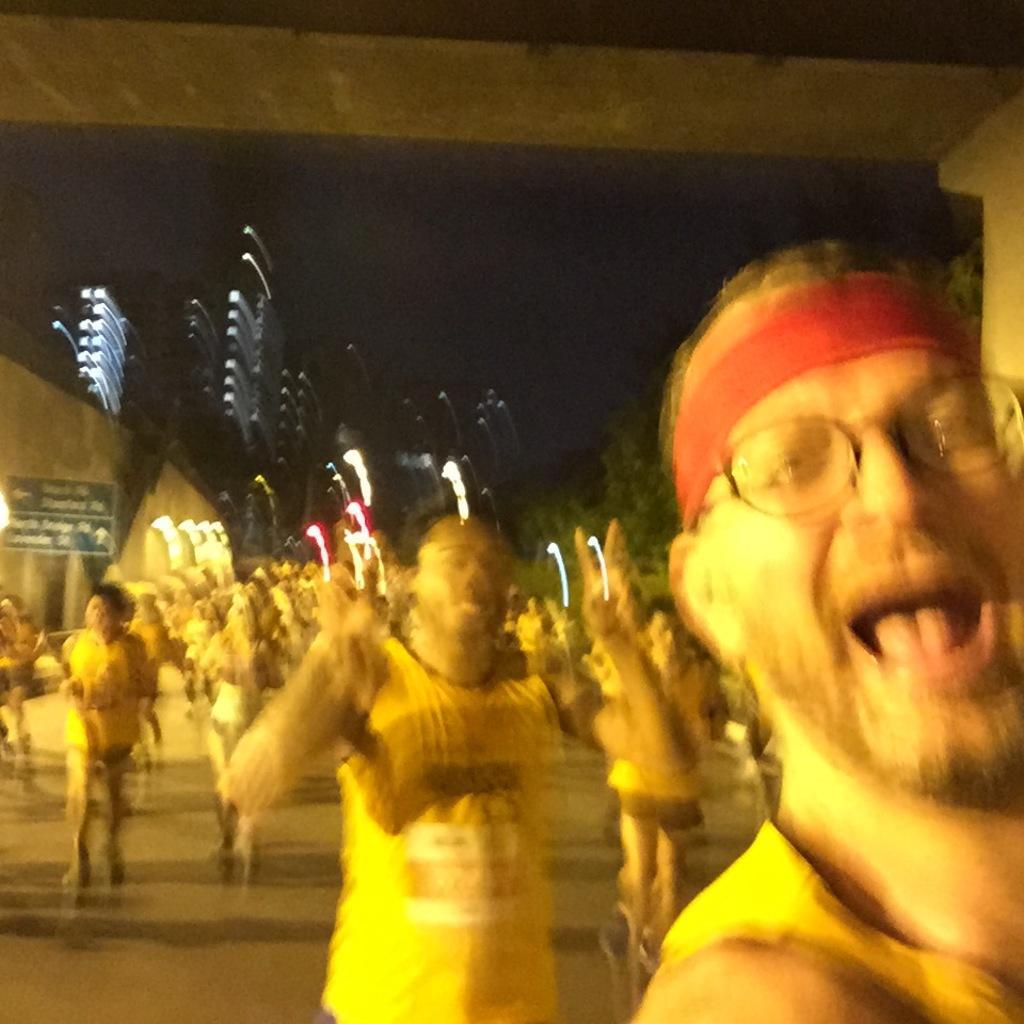In one or two sentences, can you explain what this image depicts? In this image we can see people standing and we can also see lights and trees. 